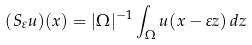<formula> <loc_0><loc_0><loc_500><loc_500>( S _ { \varepsilon } u ) ( x ) = | \Omega | ^ { - 1 } \int _ { \Omega } u ( x - \varepsilon z ) \, d z</formula> 